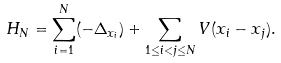Convert formula to latex. <formula><loc_0><loc_0><loc_500><loc_500>H _ { N } = \sum _ { i = 1 } ^ { N } ( - \Delta _ { x _ { i } } ) + \sum _ { 1 \leq i < j \leq N } V ( x _ { i } - x _ { j } ) .</formula> 